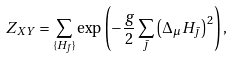Convert formula to latex. <formula><loc_0><loc_0><loc_500><loc_500>Z _ { X Y } = \sum _ { \{ H _ { \bar { \jmath } } \} } \exp \left ( - \frac { g } { 2 } \sum _ { \bar { \jmath } } \left ( \Delta _ { \mu } H _ { \bar { \jmath } } \right ) ^ { 2 } \right ) ,</formula> 